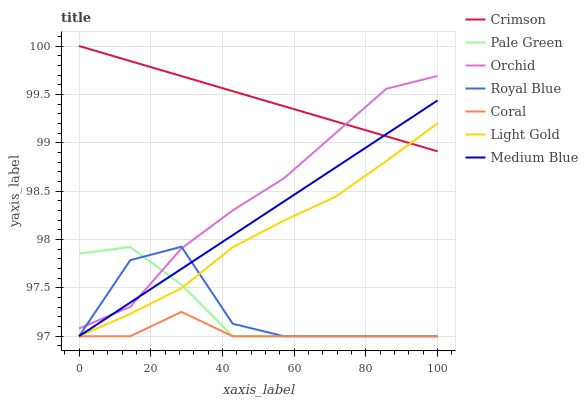Does Coral have the minimum area under the curve?
Answer yes or no. Yes. Does Crimson have the maximum area under the curve?
Answer yes or no. Yes. Does Medium Blue have the minimum area under the curve?
Answer yes or no. No. Does Medium Blue have the maximum area under the curve?
Answer yes or no. No. Is Crimson the smoothest?
Answer yes or no. Yes. Is Royal Blue the roughest?
Answer yes or no. Yes. Is Medium Blue the smoothest?
Answer yes or no. No. Is Medium Blue the roughest?
Answer yes or no. No. Does Coral have the lowest value?
Answer yes or no. Yes. Does Crimson have the lowest value?
Answer yes or no. No. Does Crimson have the highest value?
Answer yes or no. Yes. Does Medium Blue have the highest value?
Answer yes or no. No. Is Light Gold less than Orchid?
Answer yes or no. Yes. Is Orchid greater than Light Gold?
Answer yes or no. Yes. Does Pale Green intersect Light Gold?
Answer yes or no. Yes. Is Pale Green less than Light Gold?
Answer yes or no. No. Is Pale Green greater than Light Gold?
Answer yes or no. No. Does Light Gold intersect Orchid?
Answer yes or no. No. 